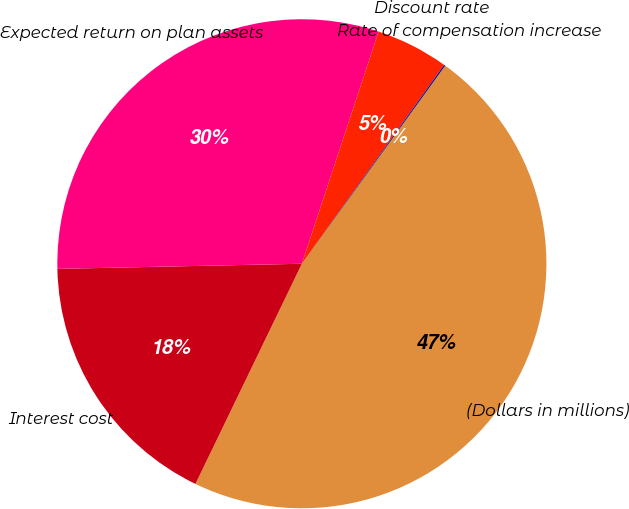<chart> <loc_0><loc_0><loc_500><loc_500><pie_chart><fcel>(Dollars in millions)<fcel>Interest cost<fcel>Expected return on plan assets<fcel>Discount rate<fcel>Rate of compensation increase<nl><fcel>47.19%<fcel>17.5%<fcel>30.41%<fcel>4.8%<fcel>0.09%<nl></chart> 